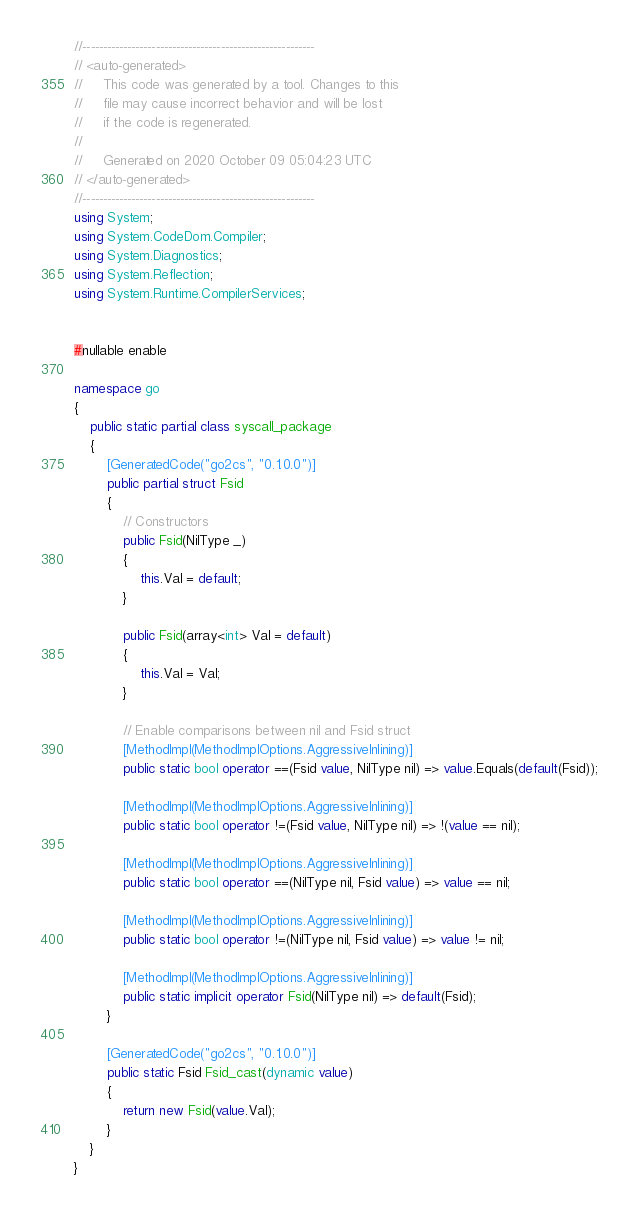<code> <loc_0><loc_0><loc_500><loc_500><_C#_>//---------------------------------------------------------
// <auto-generated>
//     This code was generated by a tool. Changes to this
//     file may cause incorrect behavior and will be lost
//     if the code is regenerated.
//
//     Generated on 2020 October 09 05:04:23 UTC
// </auto-generated>
//---------------------------------------------------------
using System;
using System.CodeDom.Compiler;
using System.Diagnostics;
using System.Reflection;
using System.Runtime.CompilerServices;


#nullable enable

namespace go
{
    public static partial class syscall_package
    {
        [GeneratedCode("go2cs", "0.1.0.0")]
        public partial struct Fsid
        {
            // Constructors
            public Fsid(NilType _)
            {
                this.Val = default;
            }

            public Fsid(array<int> Val = default)
            {
                this.Val = Val;
            }

            // Enable comparisons between nil and Fsid struct
            [MethodImpl(MethodImplOptions.AggressiveInlining)]
            public static bool operator ==(Fsid value, NilType nil) => value.Equals(default(Fsid));

            [MethodImpl(MethodImplOptions.AggressiveInlining)]
            public static bool operator !=(Fsid value, NilType nil) => !(value == nil);

            [MethodImpl(MethodImplOptions.AggressiveInlining)]
            public static bool operator ==(NilType nil, Fsid value) => value == nil;

            [MethodImpl(MethodImplOptions.AggressiveInlining)]
            public static bool operator !=(NilType nil, Fsid value) => value != nil;

            [MethodImpl(MethodImplOptions.AggressiveInlining)]
            public static implicit operator Fsid(NilType nil) => default(Fsid);
        }

        [GeneratedCode("go2cs", "0.1.0.0")]
        public static Fsid Fsid_cast(dynamic value)
        {
            return new Fsid(value.Val);
        }
    }
}</code> 